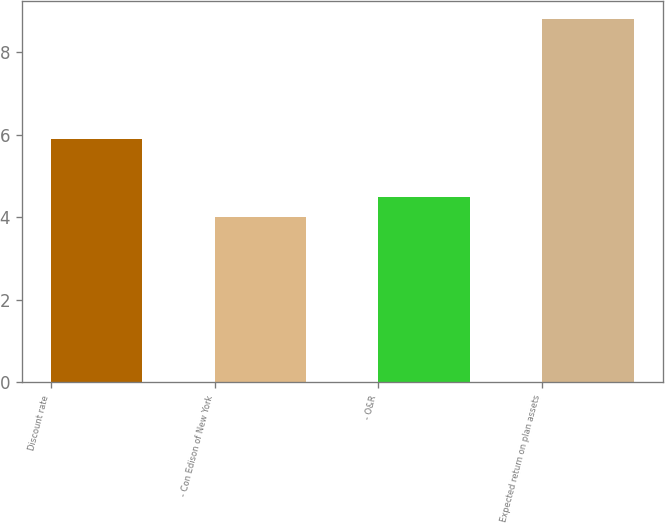Convert chart to OTSL. <chart><loc_0><loc_0><loc_500><loc_500><bar_chart><fcel>Discount rate<fcel>- Con Edison of New York<fcel>- O&R<fcel>Expected return on plan assets<nl><fcel>5.9<fcel>4<fcel>4.48<fcel>8.8<nl></chart> 